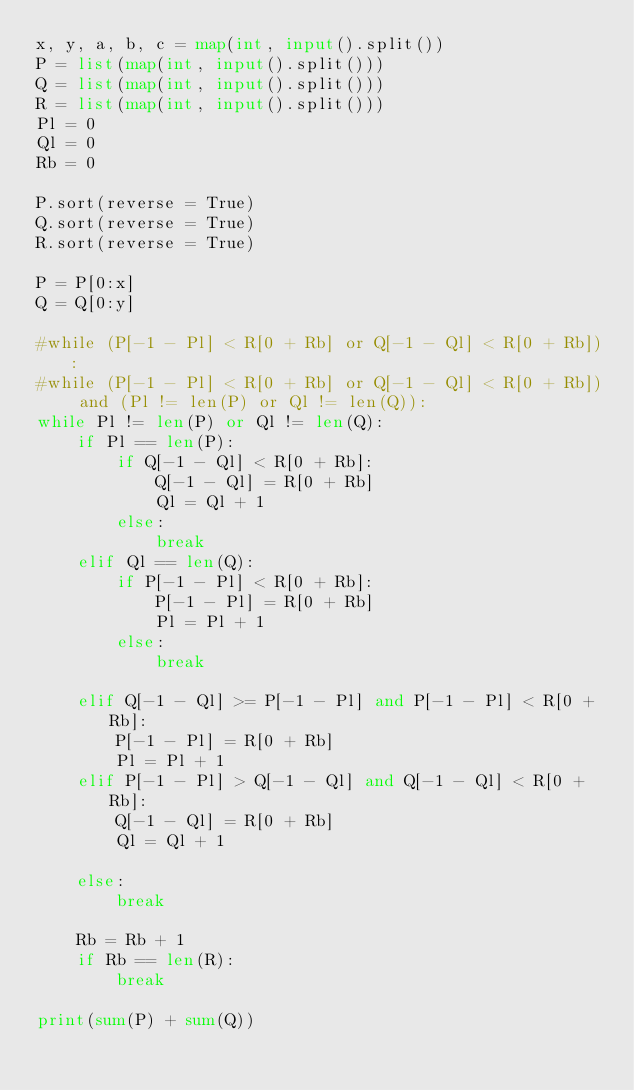<code> <loc_0><loc_0><loc_500><loc_500><_Python_>x, y, a, b, c = map(int, input().split())
P = list(map(int, input().split()))
Q = list(map(int, input().split()))
R = list(map(int, input().split()))
Pl = 0
Ql = 0
Rb = 0

P.sort(reverse = True)
Q.sort(reverse = True)
R.sort(reverse = True)

P = P[0:x]
Q = Q[0:y]

#while (P[-1 - Pl] < R[0 + Rb] or Q[-1 - Ql] < R[0 + Rb]):
#while (P[-1 - Pl] < R[0 + Rb] or Q[-1 - Ql] < R[0 + Rb]) and (Pl != len(P) or Ql != len(Q)):
while Pl != len(P) or Ql != len(Q):
    if Pl == len(P):
        if Q[-1 - Ql] < R[0 + Rb]:
            Q[-1 - Ql] = R[0 + Rb]
            Ql = Ql + 1
        else:
            break
    elif Ql == len(Q):
        if P[-1 - Pl] < R[0 + Rb]:
            P[-1 - Pl] = R[0 + Rb]
            Pl = Pl + 1
        else:
            break

    elif Q[-1 - Ql] >= P[-1 - Pl] and P[-1 - Pl] < R[0 + Rb]:
        P[-1 - Pl] = R[0 + Rb]
        Pl = Pl + 1
    elif P[-1 - Pl] > Q[-1 - Ql] and Q[-1 - Ql] < R[0 + Rb]:
        Q[-1 - Ql] = R[0 + Rb]
        Ql = Ql + 1

    else:
        break

    Rb = Rb + 1
    if Rb == len(R):
        break

print(sum(P) + sum(Q))</code> 